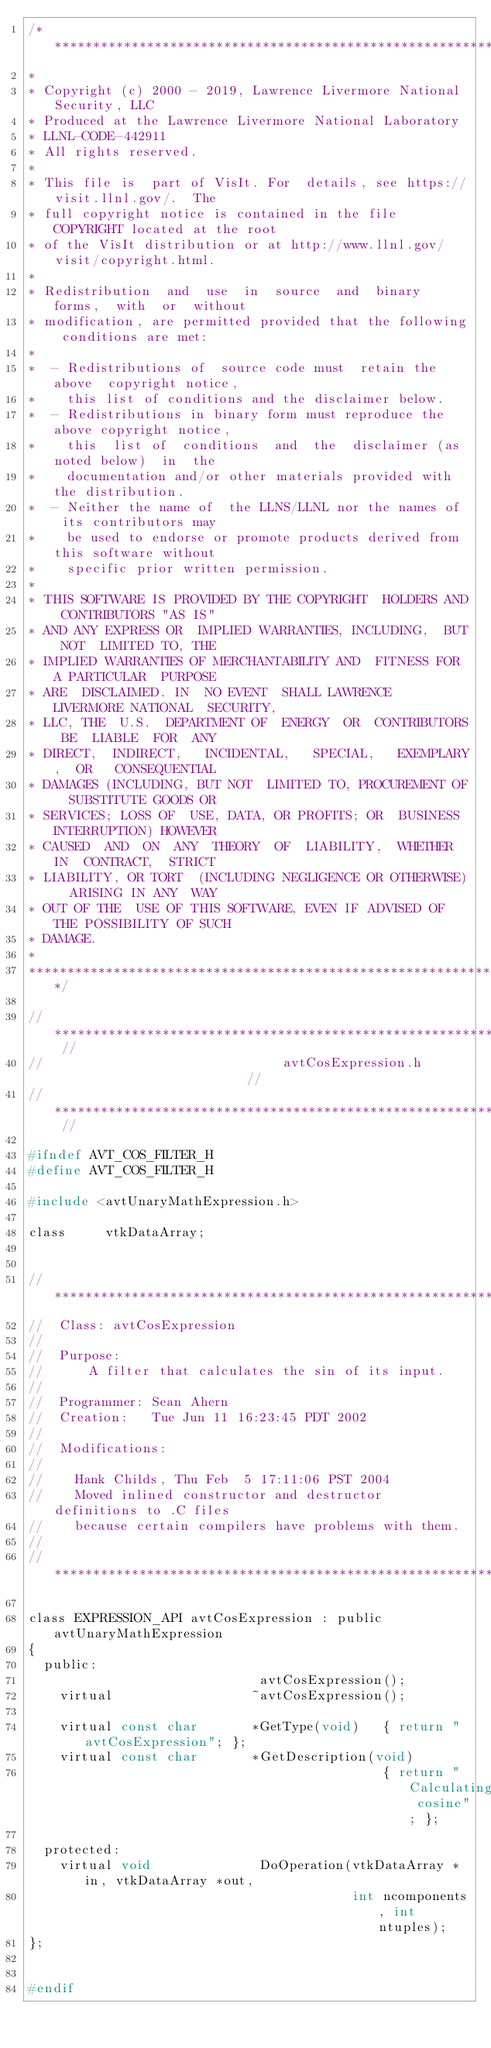Convert code to text. <code><loc_0><loc_0><loc_500><loc_500><_C_>/*****************************************************************************
*
* Copyright (c) 2000 - 2019, Lawrence Livermore National Security, LLC
* Produced at the Lawrence Livermore National Laboratory
* LLNL-CODE-442911
* All rights reserved.
*
* This file is  part of VisIt. For  details, see https://visit.llnl.gov/.  The
* full copyright notice is contained in the file COPYRIGHT located at the root
* of the VisIt distribution or at http://www.llnl.gov/visit/copyright.html.
*
* Redistribution  and  use  in  source  and  binary  forms,  with  or  without
* modification, are permitted provided that the following conditions are met:
*
*  - Redistributions of  source code must  retain the above  copyright notice,
*    this list of conditions and the disclaimer below.
*  - Redistributions in binary form must reproduce the above copyright notice,
*    this  list of  conditions  and  the  disclaimer (as noted below)  in  the
*    documentation and/or other materials provided with the distribution.
*  - Neither the name of  the LLNS/LLNL nor the names of  its contributors may
*    be used to endorse or promote products derived from this software without
*    specific prior written permission.
*
* THIS SOFTWARE IS PROVIDED BY THE COPYRIGHT  HOLDERS AND CONTRIBUTORS "AS IS"
* AND ANY EXPRESS OR  IMPLIED WARRANTIES, INCLUDING,  BUT NOT  LIMITED TO, THE
* IMPLIED WARRANTIES OF MERCHANTABILITY AND  FITNESS FOR A PARTICULAR  PURPOSE
* ARE  DISCLAIMED. IN  NO EVENT  SHALL LAWRENCE  LIVERMORE NATIONAL  SECURITY,
* LLC, THE  U.S.  DEPARTMENT OF  ENERGY  OR  CONTRIBUTORS BE  LIABLE  FOR  ANY
* DIRECT,  INDIRECT,   INCIDENTAL,   SPECIAL,   EXEMPLARY,  OR   CONSEQUENTIAL
* DAMAGES (INCLUDING, BUT NOT  LIMITED TO, PROCUREMENT OF  SUBSTITUTE GOODS OR
* SERVICES; LOSS OF  USE, DATA, OR PROFITS; OR  BUSINESS INTERRUPTION) HOWEVER
* CAUSED  AND  ON  ANY  THEORY  OF  LIABILITY,  WHETHER  IN  CONTRACT,  STRICT
* LIABILITY, OR TORT  (INCLUDING NEGLIGENCE OR OTHERWISE)  ARISING IN ANY  WAY
* OUT OF THE  USE OF THIS SOFTWARE, EVEN IF ADVISED OF THE POSSIBILITY OF SUCH
* DAMAGE.
*
*****************************************************************************/

// ************************************************************************* //
//                               avtCosExpression.h                          //
// ************************************************************************* //

#ifndef AVT_COS_FILTER_H
#define AVT_COS_FILTER_H

#include <avtUnaryMathExpression.h>

class     vtkDataArray;


// ****************************************************************************
//  Class: avtCosExpression
//
//  Purpose:
//      A filter that calculates the sin of its input.
//
//  Programmer: Sean Ahern
//  Creation:   Tue Jun 11 16:23:45 PDT 2002
//
//  Modifications:
//
//    Hank Childs, Thu Feb  5 17:11:06 PST 2004
//    Moved inlined constructor and destructor definitions to .C files
//    because certain compilers have problems with them.
//
// ****************************************************************************

class EXPRESSION_API avtCosExpression : public avtUnaryMathExpression
{
  public:
                              avtCosExpression();
    virtual                  ~avtCosExpression();

    virtual const char       *GetType(void)   { return "avtCosExpression"; };
    virtual const char       *GetDescription(void) 
                                              { return "Calculating cosine"; };

  protected:
    virtual void              DoOperation(vtkDataArray *in, vtkDataArray *out,
                                          int ncomponents, int ntuples);
};


#endif


</code> 